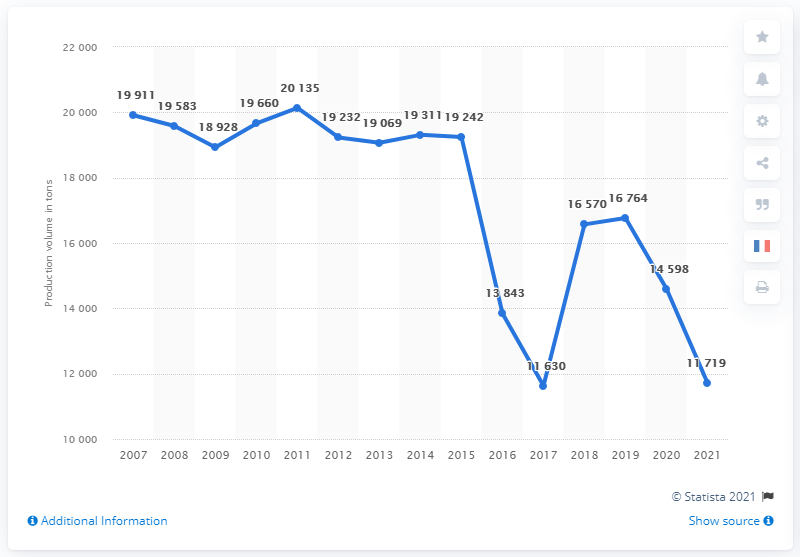Mention a couple of crucial points in this snapshot. The annual production of duck and goose Foie Gras in France from 2007 to 2015 was approximately 19,069 metric tons. The expected amount of duck and goose Foie Gras produced in 2021 is 11,719 metric tons. 